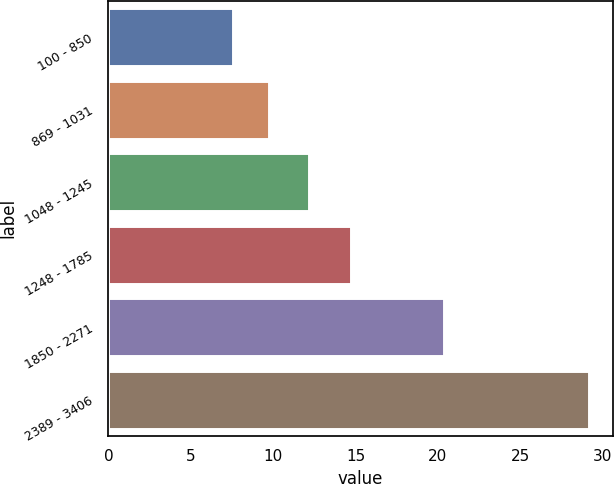<chart> <loc_0><loc_0><loc_500><loc_500><bar_chart><fcel>100 - 850<fcel>869 - 1031<fcel>1048 - 1245<fcel>1248 - 1785<fcel>1850 - 2271<fcel>2389 - 3406<nl><fcel>7.58<fcel>9.74<fcel>12.15<fcel>14.71<fcel>20.36<fcel>29.16<nl></chart> 